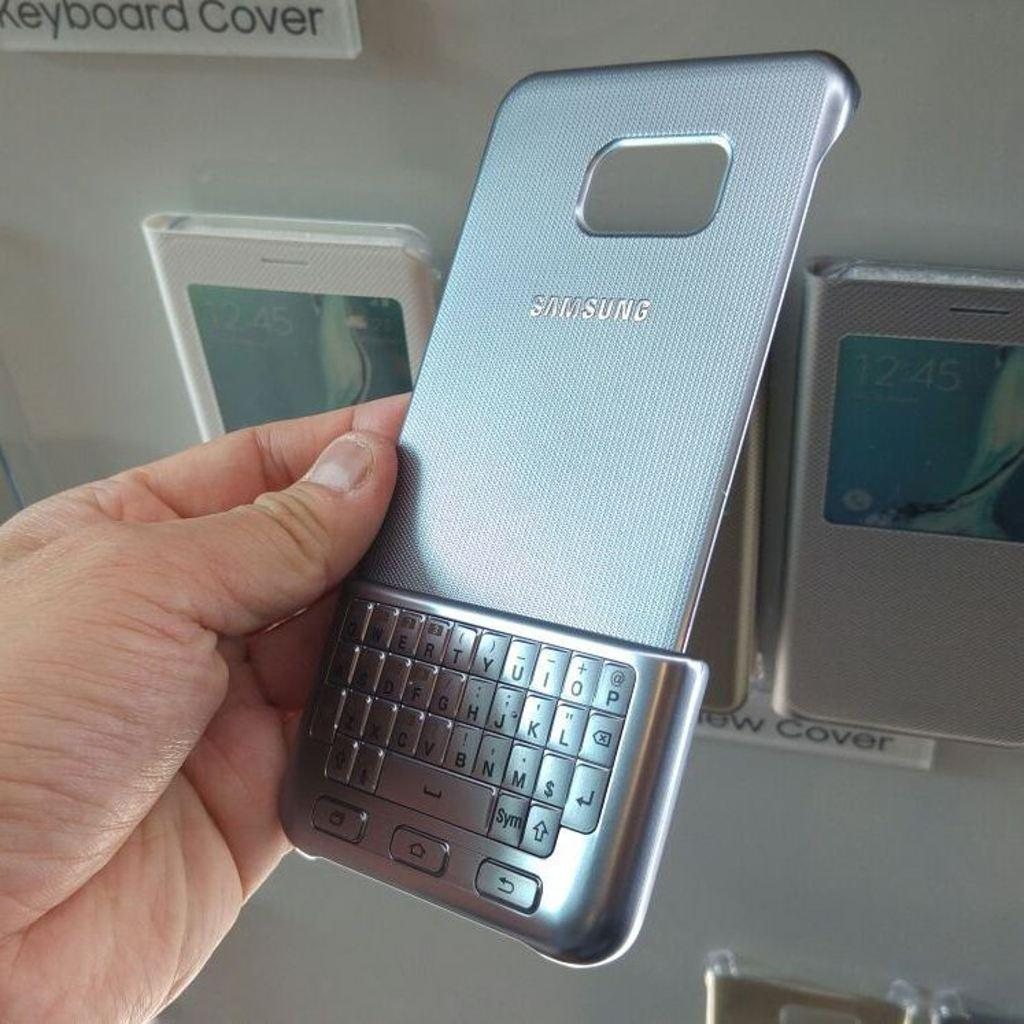What is the person holding in the image? There is a hand holding a keypad in the image. What type of device is the keypad part of? The keypad is part of a mobile device. What else can be seen on the mobile device? The back panel of a mobile is visible in the image. What is present in the background of the image? There are mobile covers in the background of the image. How are the mobile covers positioned in the image? The mobile covers appear to be attached to an object. What type of curve can be seen on the window in the image? There is no window present in the image; it features a hand holding a keypad and mobile device components. 